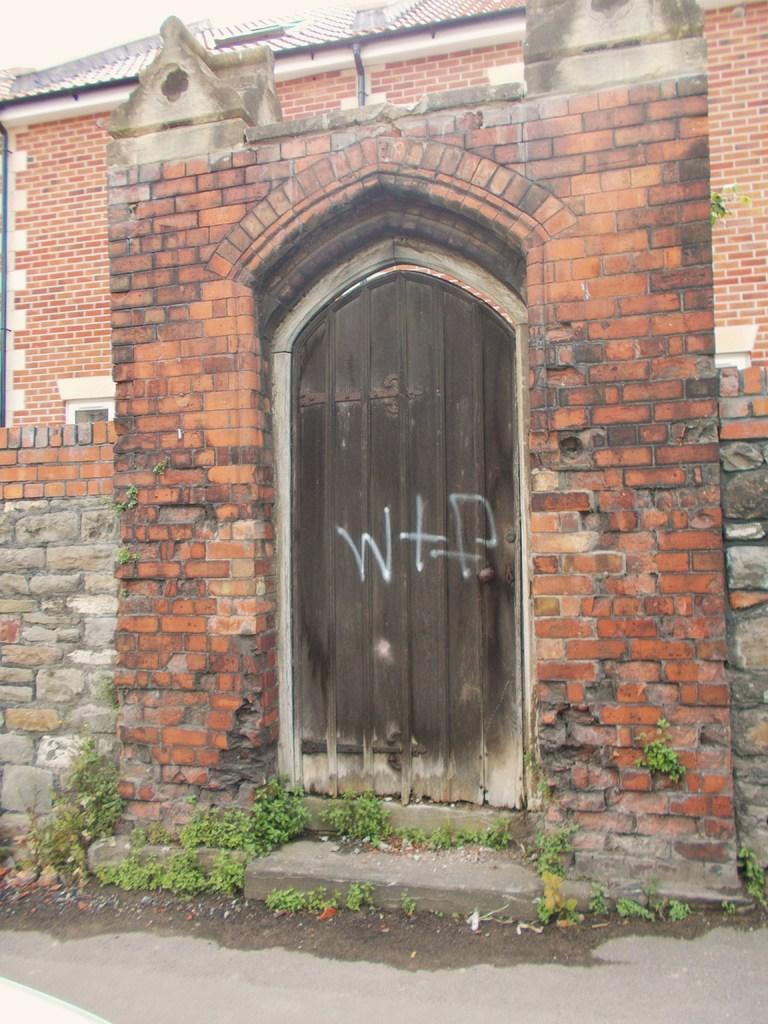In one or two sentences, can you explain what this image depicts? In this image we can see a building with door, pipes and roof. In the foreground of the image we can see some plants. At the top of the image we can see the sky. 